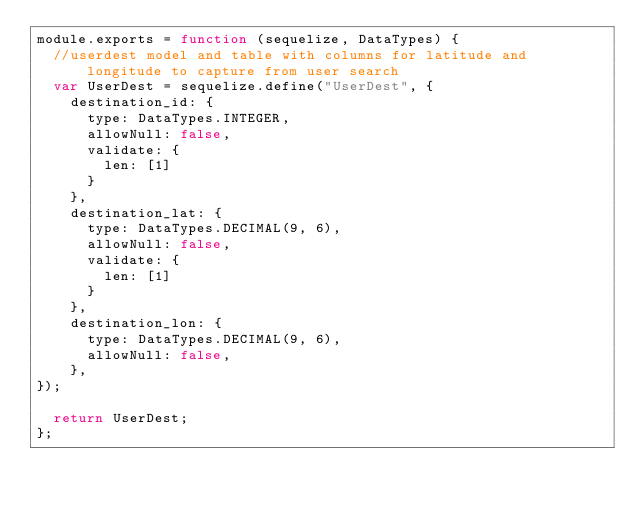<code> <loc_0><loc_0><loc_500><loc_500><_JavaScript_>module.exports = function (sequelize, DataTypes) {
  //userdest model and table with columns for latitude and longitude to capture from user search
  var UserDest = sequelize.define("UserDest", {
    destination_id: {
      type: DataTypes.INTEGER,
      allowNull: false,
      validate: {
        len: [1]
      }
    },
    destination_lat: {
      type: DataTypes.DECIMAL(9, 6),
      allowNull: false,
      validate: {
        len: [1]
      }
    },
    destination_lon: {
      type: DataTypes.DECIMAL(9, 6),
      allowNull: false,
    },
});
  
  return UserDest;
};


</code> 